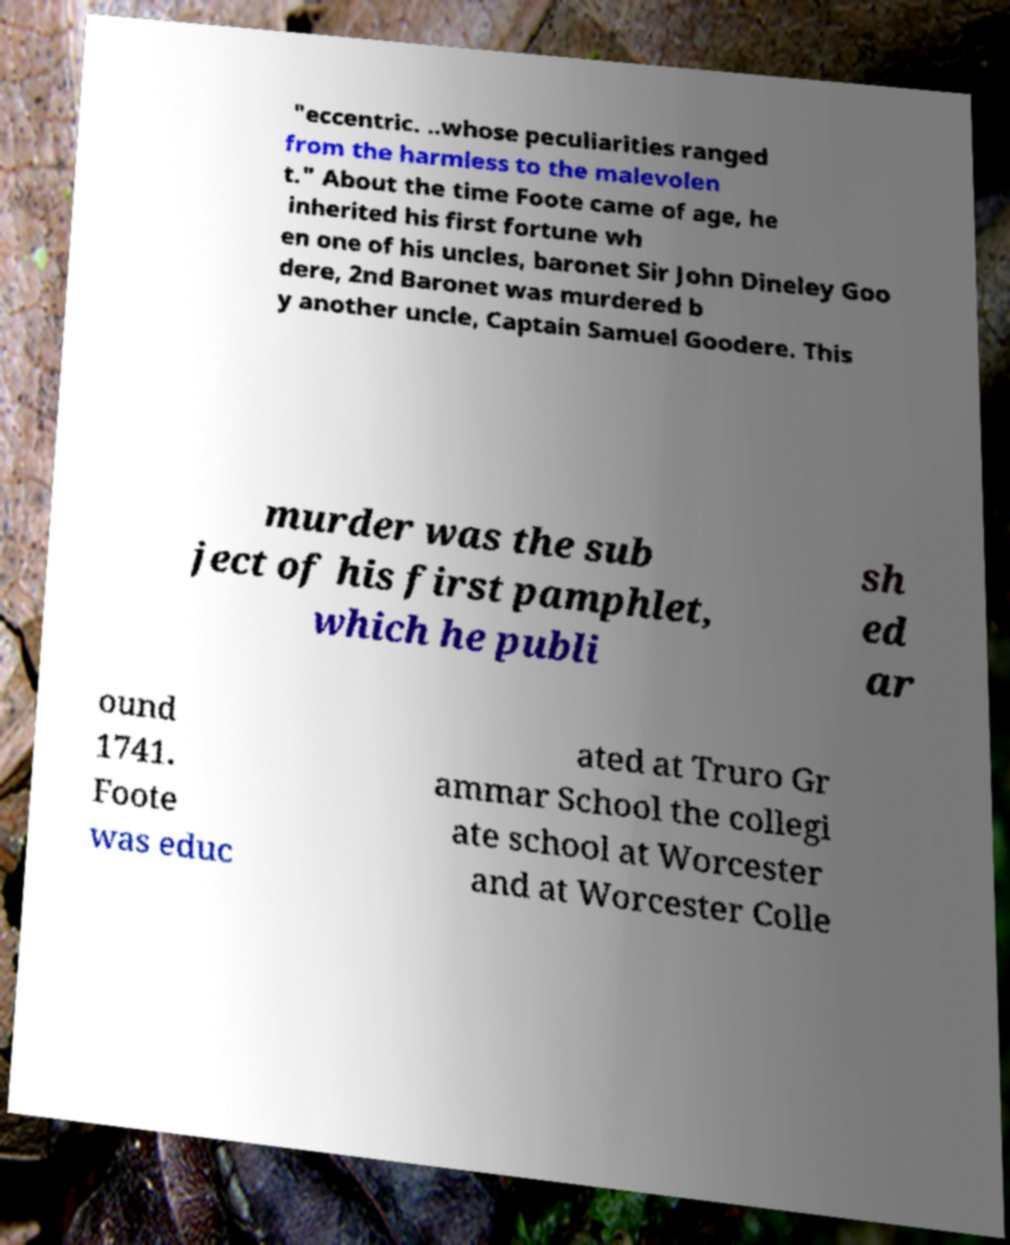Could you extract and type out the text from this image? "eccentric. ..whose peculiarities ranged from the harmless to the malevolen t." About the time Foote came of age, he inherited his first fortune wh en one of his uncles, baronet Sir John Dineley Goo dere, 2nd Baronet was murdered b y another uncle, Captain Samuel Goodere. This murder was the sub ject of his first pamphlet, which he publi sh ed ar ound 1741. Foote was educ ated at Truro Gr ammar School the collegi ate school at Worcester and at Worcester Colle 